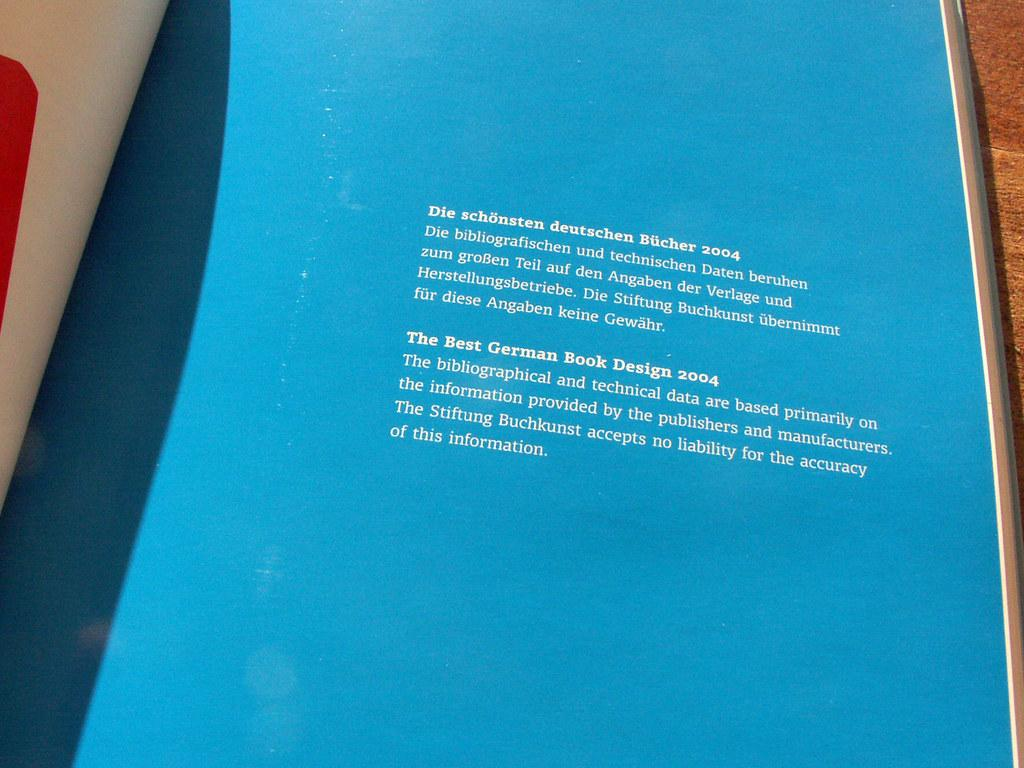<image>
Relay a brief, clear account of the picture shown. a blue sign that has many words, the first of which is die 